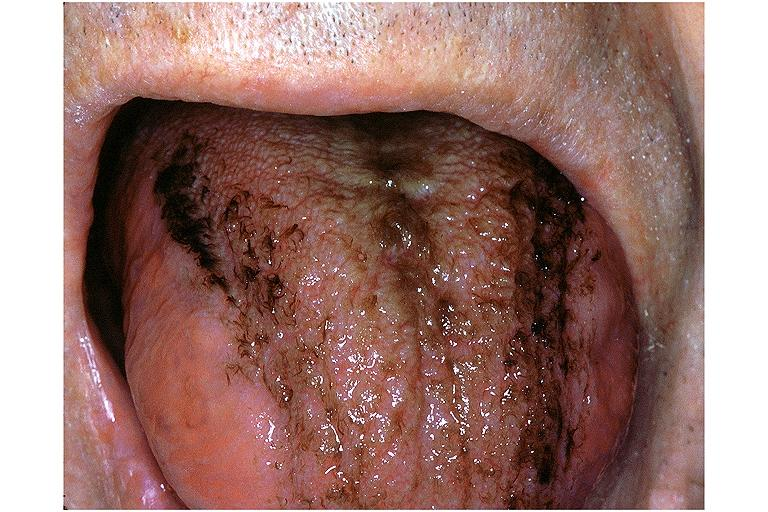what is present?
Answer the question using a single word or phrase. Oral 